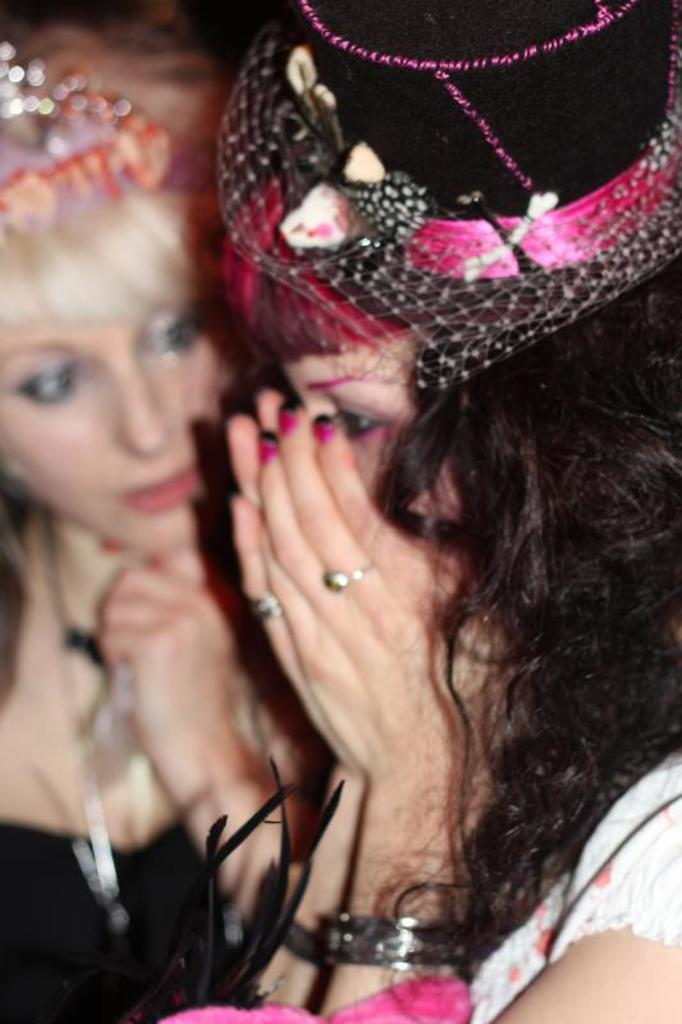How many people are in the image? There are two women in the image. What is a notable feature of the women in the image? The women have objects on their heads. What type of sand can be seen on the zebra's back in the image? There is no sand or zebra present in the image. 